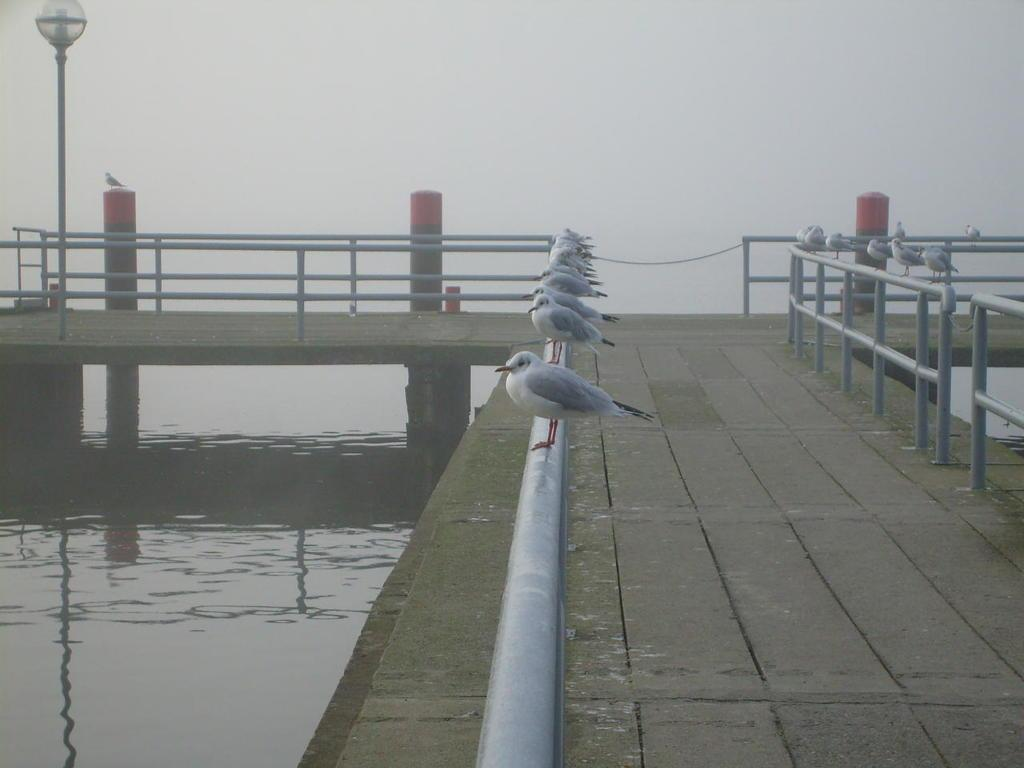What animals can be seen on the railing in the image? There are birds on the railing in the image. What structure is in the foreground of the image? There is a bridge in the foreground of the image. What feature is present on the bridge? There is a railing on the bridge. What object can be seen on the bridge? There is a pole on the bridge. What is visible at the bottom of the image? There is water at the bottom of the image. What type of payment is required to cross the bridge in the image? There is no indication of any payment required to cross the bridge in the image. What kind of vase can be seen on the railing with the birds? There is no vase present on the railing with the birds in the image. 